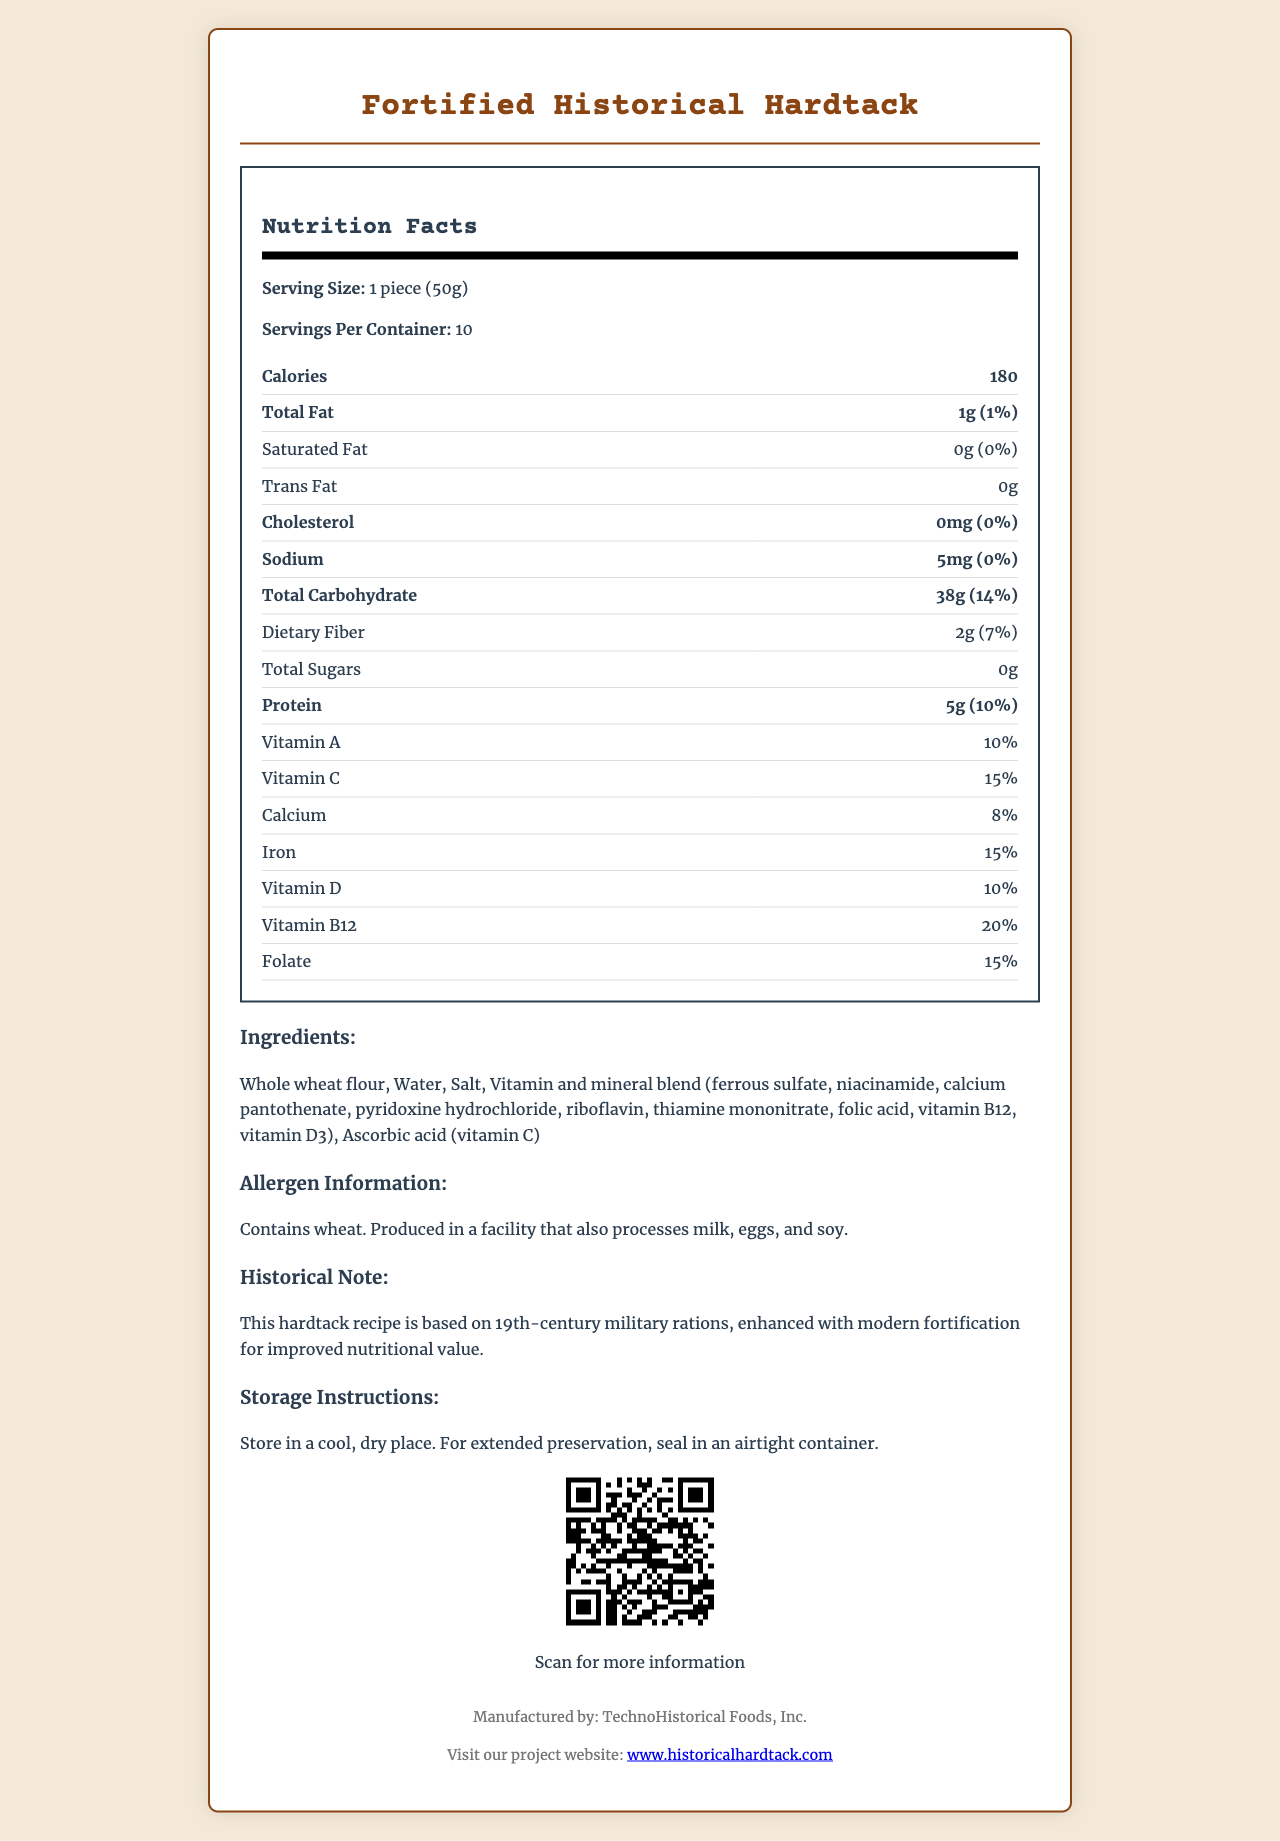what is the serving size? The serving size is clearly stated in the document under the Nutrition Facts section.
Answer: 1 piece (50g) how many servings per container are there? The servings per container are specified as 10 in the Nutrition Facts section.
Answer: 10 what is the calorie content per serving? The document shows that each serving contains 180 calories.
Answer: 180 how much sodium does each serving of this hardtack contain? The sodium content per serving is listed as 5mg in the Nutrition Facts.
Answer: 5mg what is the percentage daily value of iron per serving? The percentage daily value of iron is given as 15%.
Answer: 15% which of the following vitamins does the hardtack fortification include? A. Vitamin E B. Vitamin D C. Vitamin K D. Vitamin B6 The Nutrition Facts list includes Vitamin D and not Vitamin E, Vitamin K, or Vitamin B6.
Answer: B. Vitamin D which ingredient is NOT part of the hardtack recipe? A. Whole wheat flour B. Vitamin and mineral blend C. Sugar D. Water The ingredients listed do not include sugar.
Answer: C. Sugar is this hardtack gluten-free? The allergen information states that it contains wheat, which means it is not gluten-free.
Answer: No what makes this hardtack historically significant? The historical note mentions that the hardtack is based on 19th-century military rations and has been enhanced with vitamins and minerals for modern nutritional value.
Answer: Based on 19th-century military rations, enhanced with modern fortification describe the storage instructions for this hardtack. The storage instructions are provided in the document, advising to store the hardtack in a cool, dry place and use an airtight container for extended preservation.
Answer: Store in a cool, dry place. For extended preservation, seal in an airtight container. who is the manufacturer of the fortified historical hardtack? The document lists TechnoHistorical Foods, Inc. as the manufacturer.
Answer: TechnoHistorical Foods, Inc. what is the percentage daily value of dietary fiber in each serving? The daily value percentage for dietary fiber in each serving is given as 7%.
Answer: 7% what specific vitamins are included in the fortification? These vitamins are listed under the Nutrition Facts as part of the fortification.
Answer: Vitamin A, Vitamin C, Vitamin D, Vitamin B12, Folate how many grams of carbohydrates are in one serving? The total carbohydrate content per serving is listed as 38g.
Answer: 38g what is the link to the project website? The project website link is provided at the bottom of the document.
Answer: www.historicalhardtack.com What is the total amount of fat in two servings? Since each serving contains 1g of total fat, two servings would contain 2g of fat.
Answer: 2g how does the hardtack get its flavor? The document does not provide any information about how the hardtack gets its flavor.
Answer: Cannot be determined Summarize the main idea of the document. The document serves to inform the reader about the nutritional content and the historical significance of the Fortified Historical Hardtack, along with necessary storage and contact information.
Answer: The document provides nutritional information for Fortified Historical Hardtack, a product based on 19th-century military rations but enhanced with modern vitamins and minerals. It includes details on serving size, calories, nutrient content, ingredients, allergen information, historical significance, and storage instructions. 